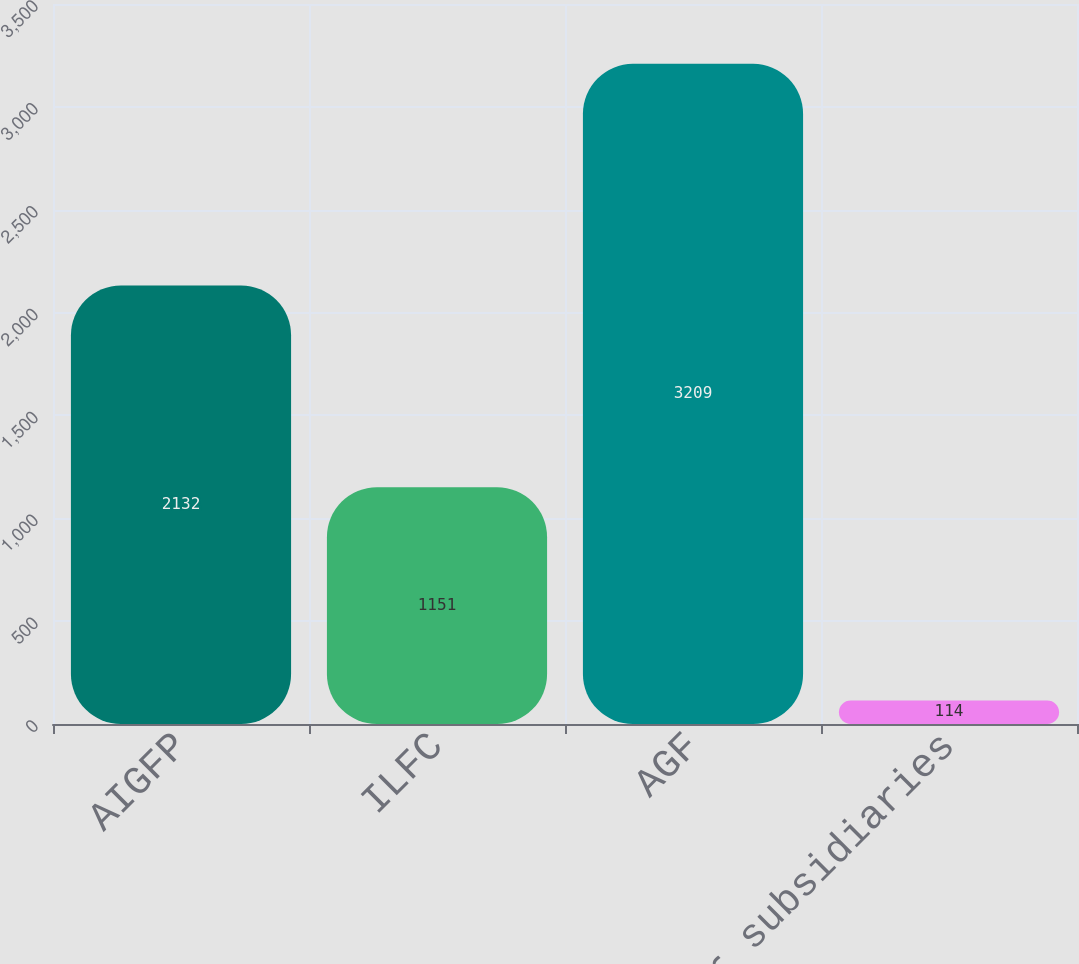<chart> <loc_0><loc_0><loc_500><loc_500><bar_chart><fcel>AIGFP<fcel>ILFC<fcel>AGF<fcel>Other subsidiaries<nl><fcel>2132<fcel>1151<fcel>3209<fcel>114<nl></chart> 